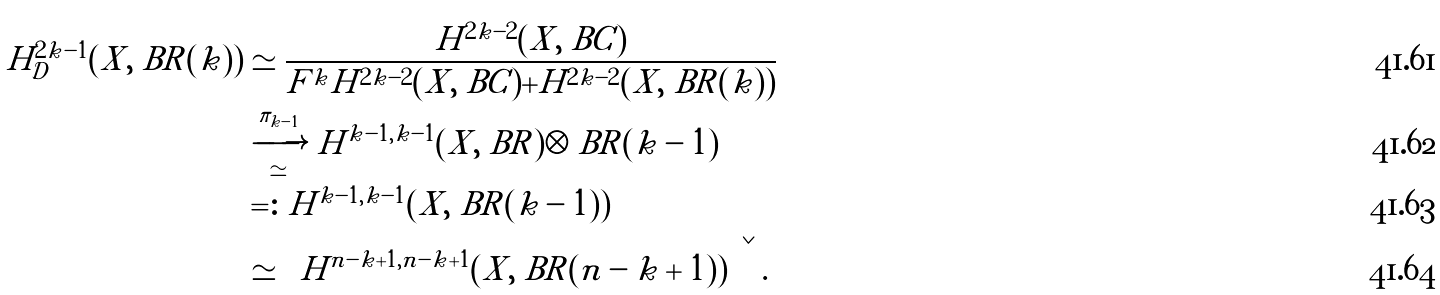Convert formula to latex. <formula><loc_0><loc_0><loc_500><loc_500>H ^ { 2 k - 1 } _ { \mathcal { D } } ( X , { \ B R } ( k ) ) & \simeq \frac { H ^ { 2 k - 2 } ( X , \ B C ) } { F ^ { k } H ^ { 2 k - 2 } ( X , \ B C ) + H ^ { 2 k - 2 } ( X , { \ B R } ( k ) ) } \\ & \xrightarrow [ \simeq ] { \pi _ { k - 1 } } H ^ { k - 1 , k - 1 } ( X , { \ B R } ) \otimes { \ B R } ( k - 1 ) \\ & = \colon H ^ { k - 1 , k - 1 } ( X , { \ B R } ( k - 1 ) ) \\ & \simeq \left \{ H ^ { n - k + 1 , n - k + 1 } ( X , { \ B R } ( n - k + 1 ) ) \right \} ^ { \vee } .</formula> 